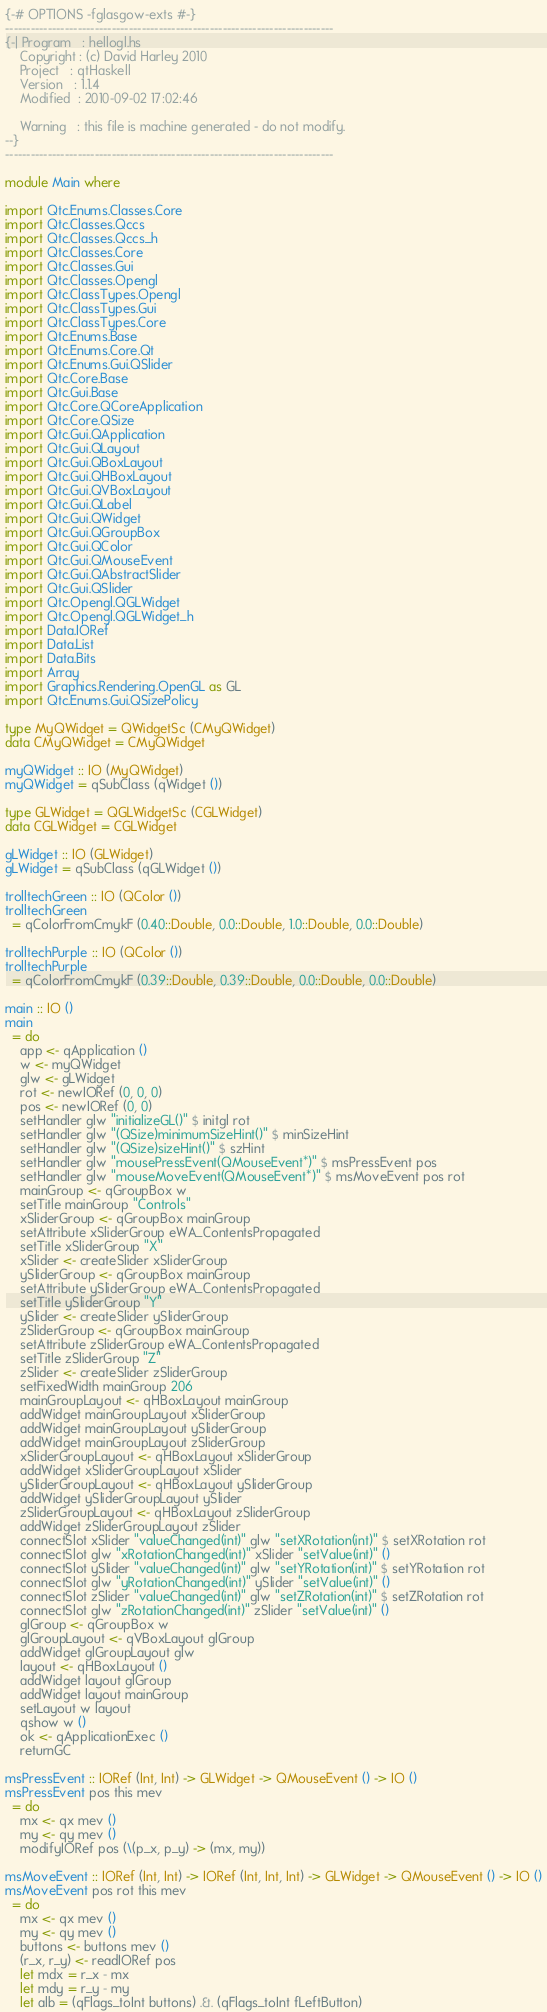Convert code to text. <code><loc_0><loc_0><loc_500><loc_500><_Haskell_>{-# OPTIONS -fglasgow-exts #-}
-----------------------------------------------------------------------------
{-| Program   : hellogl.hs
    Copyright : (c) David Harley 2010
    Project   : qtHaskell
    Version   : 1.1.4
    Modified  : 2010-09-02 17:02:46
    
    Warning   : this file is machine generated - do not modify.
--}
-----------------------------------------------------------------------------

module Main where

import Qtc.Enums.Classes.Core
import Qtc.Classes.Qccs
import Qtc.Classes.Qccs_h
import Qtc.Classes.Core
import Qtc.Classes.Gui
import Qtc.Classes.Opengl
import Qtc.ClassTypes.Opengl
import Qtc.ClassTypes.Gui
import Qtc.ClassTypes.Core
import Qtc.Enums.Base
import Qtc.Enums.Core.Qt
import Qtc.Enums.Gui.QSlider
import Qtc.Core.Base
import Qtc.Gui.Base
import Qtc.Core.QCoreApplication
import Qtc.Core.QSize
import Qtc.Gui.QApplication
import Qtc.Gui.QLayout
import Qtc.Gui.QBoxLayout
import Qtc.Gui.QHBoxLayout
import Qtc.Gui.QVBoxLayout
import Qtc.Gui.QLabel
import Qtc.Gui.QWidget
import Qtc.Gui.QGroupBox
import Qtc.Gui.QColor
import Qtc.Gui.QMouseEvent
import Qtc.Gui.QAbstractSlider
import Qtc.Gui.QSlider
import Qtc.Opengl.QGLWidget
import Qtc.Opengl.QGLWidget_h
import Data.IORef
import Data.List
import Data.Bits
import Array
import Graphics.Rendering.OpenGL as GL
import Qtc.Enums.Gui.QSizePolicy

type MyQWidget = QWidgetSc (CMyQWidget)
data CMyQWidget = CMyQWidget

myQWidget :: IO (MyQWidget)
myQWidget = qSubClass (qWidget ())

type GLWidget = QGLWidgetSc (CGLWidget)
data CGLWidget = CGLWidget

gLWidget :: IO (GLWidget)
gLWidget = qSubClass (qGLWidget ())

trolltechGreen :: IO (QColor ())
trolltechGreen
  = qColorFromCmykF (0.40::Double, 0.0::Double, 1.0::Double, 0.0::Double)

trolltechPurple :: IO (QColor ())
trolltechPurple
  = qColorFromCmykF (0.39::Double, 0.39::Double, 0.0::Double, 0.0::Double)

main :: IO ()
main
  = do
    app <- qApplication ()
    w <- myQWidget 
    glw <- gLWidget
    rot <- newIORef (0, 0, 0)
    pos <- newIORef (0, 0)
    setHandler glw "initializeGL()" $ initgl rot
    setHandler glw "(QSize)minimumSizeHint()" $ minSizeHint
    setHandler glw "(QSize)sizeHint()" $ szHint
    setHandler glw "mousePressEvent(QMouseEvent*)" $ msPressEvent pos
    setHandler glw "mouseMoveEvent(QMouseEvent*)" $ msMoveEvent pos rot
    mainGroup <- qGroupBox w
    setTitle mainGroup "Controls"
    xSliderGroup <- qGroupBox mainGroup
    setAttribute xSliderGroup eWA_ContentsPropagated
    setTitle xSliderGroup "X"
    xSlider <- createSlider xSliderGroup
    ySliderGroup <- qGroupBox mainGroup
    setAttribute ySliderGroup eWA_ContentsPropagated
    setTitle ySliderGroup "Y"
    ySlider <- createSlider ySliderGroup
    zSliderGroup <- qGroupBox mainGroup
    setAttribute zSliderGroup eWA_ContentsPropagated
    setTitle zSliderGroup "Z"
    zSlider <- createSlider zSliderGroup
    setFixedWidth mainGroup 206
    mainGroupLayout <- qHBoxLayout mainGroup
    addWidget mainGroupLayout xSliderGroup
    addWidget mainGroupLayout ySliderGroup
    addWidget mainGroupLayout zSliderGroup
    xSliderGroupLayout <- qHBoxLayout xSliderGroup
    addWidget xSliderGroupLayout xSlider
    ySliderGroupLayout <- qHBoxLayout ySliderGroup
    addWidget ySliderGroupLayout ySlider
    zSliderGroupLayout <- qHBoxLayout zSliderGroup
    addWidget zSliderGroupLayout zSlider
    connectSlot xSlider "valueChanged(int)" glw "setXRotation(int)" $ setXRotation rot
    connectSlot glw "xRotationChanged(int)" xSlider "setValue(int)" ()
    connectSlot ySlider "valueChanged(int)" glw "setYRotation(int)" $ setYRotation rot
    connectSlot glw "yRotationChanged(int)" ySlider "setValue(int)" ()
    connectSlot zSlider "valueChanged(int)" glw "setZRotation(int)" $ setZRotation rot
    connectSlot glw "zRotationChanged(int)" zSlider "setValue(int)" ()
    glGroup <- qGroupBox w
    glGroupLayout <- qVBoxLayout glGroup
    addWidget glGroupLayout glw
    layout <- qHBoxLayout ()
    addWidget layout glGroup
    addWidget layout mainGroup
    setLayout w layout
    qshow w ()
    ok <- qApplicationExec ()
    returnGC

msPressEvent :: IORef (Int, Int) -> GLWidget -> QMouseEvent () -> IO ()
msPressEvent pos this mev
  = do
    mx <- qx mev ()
    my <- qy mev ()
    modifyIORef pos (\(p_x, p_y) -> (mx, my))

msMoveEvent :: IORef (Int, Int) -> IORef (Int, Int, Int) -> GLWidget -> QMouseEvent () -> IO ()
msMoveEvent pos rot this mev
  = do
    mx <- qx mev ()
    my <- qy mev ()
    buttons <- buttons mev ()
    (r_x, r_y) <- readIORef pos
    let mdx = r_x - mx
    let mdy = r_y - my
    let alb = (qFlags_toInt buttons) .&. (qFlags_toInt fLeftButton)</code> 